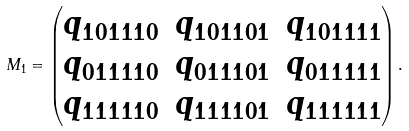Convert formula to latex. <formula><loc_0><loc_0><loc_500><loc_500>M _ { 1 } = \begin{pmatrix} q _ { 1 0 1 1 1 0 } & q _ { 1 0 1 1 0 1 } & q _ { 1 0 1 1 1 1 } \\ q _ { 0 1 1 1 1 0 } & q _ { 0 1 1 1 0 1 } & q _ { 0 1 1 1 1 1 } \\ q _ { 1 1 1 1 1 0 } & q _ { 1 1 1 1 0 1 } & q _ { 1 1 1 1 1 1 } \end{pmatrix} .</formula> 